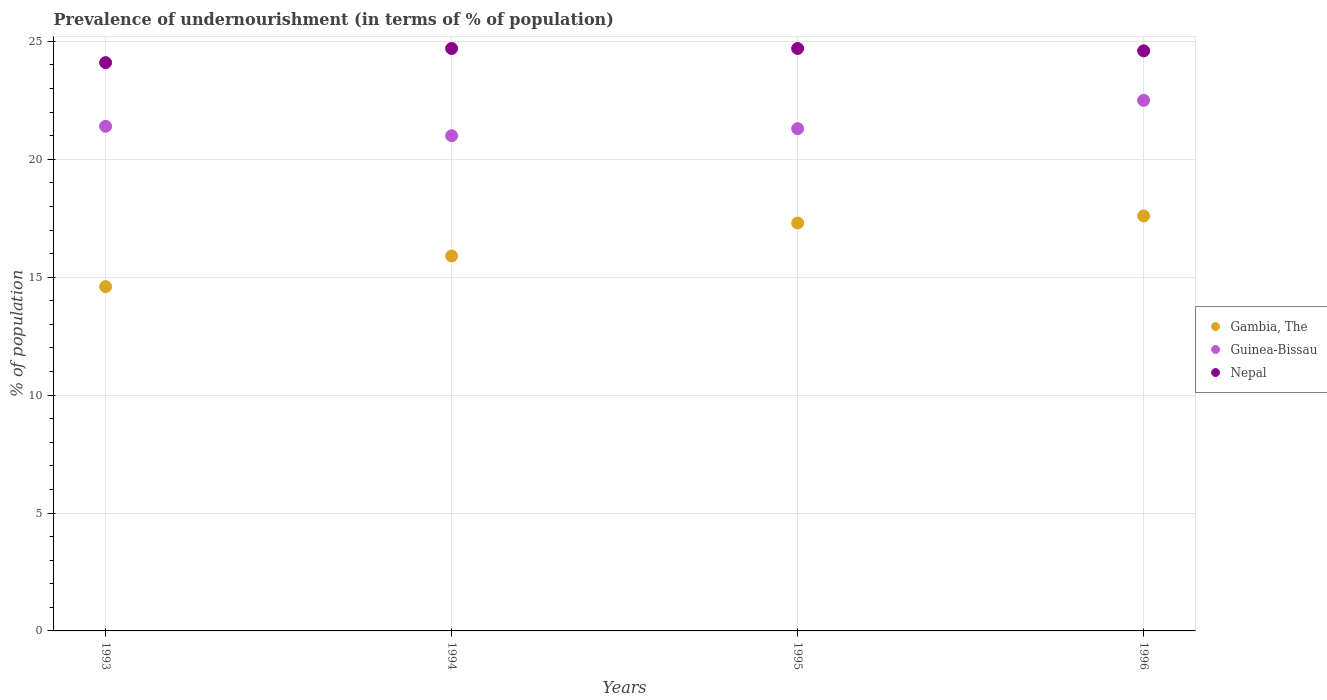What is the percentage of undernourished population in Nepal in 1993?
Make the answer very short. 24.1. Across all years, what is the maximum percentage of undernourished population in Nepal?
Provide a short and direct response. 24.7. Across all years, what is the minimum percentage of undernourished population in Nepal?
Make the answer very short. 24.1. In which year was the percentage of undernourished population in Gambia, The maximum?
Offer a very short reply. 1996. What is the total percentage of undernourished population in Gambia, The in the graph?
Make the answer very short. 65.4. What is the difference between the percentage of undernourished population in Gambia, The in 1993 and that in 1994?
Provide a succinct answer. -1.3. What is the difference between the percentage of undernourished population in Gambia, The in 1993 and the percentage of undernourished population in Nepal in 1996?
Offer a very short reply. -10. What is the average percentage of undernourished population in Nepal per year?
Make the answer very short. 24.52. In the year 1996, what is the difference between the percentage of undernourished population in Gambia, The and percentage of undernourished population in Nepal?
Make the answer very short. -7. In how many years, is the percentage of undernourished population in Nepal greater than 22 %?
Offer a very short reply. 4. What is the ratio of the percentage of undernourished population in Gambia, The in 1994 to that in 1996?
Your response must be concise. 0.9. Is the percentage of undernourished population in Guinea-Bissau in 1993 less than that in 1996?
Provide a succinct answer. Yes. Is the difference between the percentage of undernourished population in Gambia, The in 1995 and 1996 greater than the difference between the percentage of undernourished population in Nepal in 1995 and 1996?
Give a very brief answer. No. What is the difference between the highest and the lowest percentage of undernourished population in Gambia, The?
Provide a short and direct response. 3. Is the sum of the percentage of undernourished population in Gambia, The in 1994 and 1995 greater than the maximum percentage of undernourished population in Guinea-Bissau across all years?
Provide a short and direct response. Yes. Is it the case that in every year, the sum of the percentage of undernourished population in Gambia, The and percentage of undernourished population in Guinea-Bissau  is greater than the percentage of undernourished population in Nepal?
Provide a succinct answer. Yes. Is the percentage of undernourished population in Nepal strictly less than the percentage of undernourished population in Guinea-Bissau over the years?
Provide a short and direct response. No. How many dotlines are there?
Your answer should be very brief. 3. What is the difference between two consecutive major ticks on the Y-axis?
Provide a succinct answer. 5. Are the values on the major ticks of Y-axis written in scientific E-notation?
Make the answer very short. No. Does the graph contain any zero values?
Your answer should be compact. No. Does the graph contain grids?
Make the answer very short. Yes. How many legend labels are there?
Your answer should be compact. 3. What is the title of the graph?
Offer a terse response. Prevalence of undernourishment (in terms of % of population). Does "Marshall Islands" appear as one of the legend labels in the graph?
Keep it short and to the point. No. What is the label or title of the Y-axis?
Make the answer very short. % of population. What is the % of population in Guinea-Bissau in 1993?
Your answer should be compact. 21.4. What is the % of population of Nepal in 1993?
Keep it short and to the point. 24.1. What is the % of population of Guinea-Bissau in 1994?
Keep it short and to the point. 21. What is the % of population of Nepal in 1994?
Your answer should be very brief. 24.7. What is the % of population of Gambia, The in 1995?
Your answer should be very brief. 17.3. What is the % of population in Guinea-Bissau in 1995?
Provide a succinct answer. 21.3. What is the % of population in Nepal in 1995?
Keep it short and to the point. 24.7. What is the % of population of Gambia, The in 1996?
Your answer should be compact. 17.6. What is the % of population in Guinea-Bissau in 1996?
Provide a succinct answer. 22.5. What is the % of population of Nepal in 1996?
Make the answer very short. 24.6. Across all years, what is the maximum % of population of Gambia, The?
Your answer should be very brief. 17.6. Across all years, what is the maximum % of population in Guinea-Bissau?
Your answer should be compact. 22.5. Across all years, what is the maximum % of population in Nepal?
Provide a short and direct response. 24.7. Across all years, what is the minimum % of population of Nepal?
Ensure brevity in your answer.  24.1. What is the total % of population in Gambia, The in the graph?
Offer a terse response. 65.4. What is the total % of population in Guinea-Bissau in the graph?
Offer a very short reply. 86.2. What is the total % of population of Nepal in the graph?
Give a very brief answer. 98.1. What is the difference between the % of population of Gambia, The in 1993 and that in 1994?
Your answer should be compact. -1.3. What is the difference between the % of population in Guinea-Bissau in 1993 and that in 1994?
Provide a succinct answer. 0.4. What is the difference between the % of population in Gambia, The in 1993 and that in 1995?
Offer a terse response. -2.7. What is the difference between the % of population in Guinea-Bissau in 1993 and that in 1995?
Keep it short and to the point. 0.1. What is the difference between the % of population in Nepal in 1993 and that in 1995?
Keep it short and to the point. -0.6. What is the difference between the % of population in Guinea-Bissau in 1993 and that in 1996?
Ensure brevity in your answer.  -1.1. What is the difference between the % of population of Nepal in 1993 and that in 1996?
Offer a very short reply. -0.5. What is the difference between the % of population in Nepal in 1994 and that in 1995?
Offer a terse response. 0. What is the difference between the % of population in Gambia, The in 1994 and that in 1996?
Provide a short and direct response. -1.7. What is the difference between the % of population of Gambia, The in 1995 and that in 1996?
Provide a succinct answer. -0.3. What is the difference between the % of population of Nepal in 1995 and that in 1996?
Offer a very short reply. 0.1. What is the difference between the % of population in Gambia, The in 1993 and the % of population in Guinea-Bissau in 1994?
Your answer should be compact. -6.4. What is the difference between the % of population of Guinea-Bissau in 1993 and the % of population of Nepal in 1994?
Keep it short and to the point. -3.3. What is the difference between the % of population of Gambia, The in 1993 and the % of population of Nepal in 1995?
Provide a succinct answer. -10.1. What is the difference between the % of population of Guinea-Bissau in 1993 and the % of population of Nepal in 1995?
Your answer should be very brief. -3.3. What is the difference between the % of population of Gambia, The in 1993 and the % of population of Guinea-Bissau in 1996?
Provide a short and direct response. -7.9. What is the difference between the % of population of Gambia, The in 1994 and the % of population of Nepal in 1995?
Your response must be concise. -8.8. What is the difference between the % of population in Gambia, The in 1994 and the % of population in Guinea-Bissau in 1996?
Your answer should be very brief. -6.6. What is the difference between the % of population of Gambia, The in 1994 and the % of population of Nepal in 1996?
Ensure brevity in your answer.  -8.7. What is the difference between the % of population of Guinea-Bissau in 1994 and the % of population of Nepal in 1996?
Ensure brevity in your answer.  -3.6. What is the difference between the % of population in Gambia, The in 1995 and the % of population in Guinea-Bissau in 1996?
Offer a very short reply. -5.2. What is the difference between the % of population of Gambia, The in 1995 and the % of population of Nepal in 1996?
Your answer should be compact. -7.3. What is the difference between the % of population of Guinea-Bissau in 1995 and the % of population of Nepal in 1996?
Offer a terse response. -3.3. What is the average % of population in Gambia, The per year?
Your response must be concise. 16.35. What is the average % of population of Guinea-Bissau per year?
Provide a succinct answer. 21.55. What is the average % of population in Nepal per year?
Keep it short and to the point. 24.52. In the year 1993, what is the difference between the % of population in Gambia, The and % of population in Guinea-Bissau?
Keep it short and to the point. -6.8. In the year 1993, what is the difference between the % of population of Gambia, The and % of population of Nepal?
Your answer should be very brief. -9.5. In the year 1993, what is the difference between the % of population of Guinea-Bissau and % of population of Nepal?
Ensure brevity in your answer.  -2.7. In the year 1994, what is the difference between the % of population in Gambia, The and % of population in Guinea-Bissau?
Your response must be concise. -5.1. In the year 1994, what is the difference between the % of population of Guinea-Bissau and % of population of Nepal?
Provide a short and direct response. -3.7. In the year 1995, what is the difference between the % of population of Gambia, The and % of population of Nepal?
Your answer should be very brief. -7.4. In the year 1996, what is the difference between the % of population of Gambia, The and % of population of Nepal?
Provide a short and direct response. -7. What is the ratio of the % of population in Gambia, The in 1993 to that in 1994?
Your answer should be very brief. 0.92. What is the ratio of the % of population in Guinea-Bissau in 1993 to that in 1994?
Make the answer very short. 1.02. What is the ratio of the % of population of Nepal in 1993 to that in 1994?
Offer a very short reply. 0.98. What is the ratio of the % of population in Gambia, The in 1993 to that in 1995?
Your response must be concise. 0.84. What is the ratio of the % of population in Guinea-Bissau in 1993 to that in 1995?
Make the answer very short. 1. What is the ratio of the % of population of Nepal in 1993 to that in 1995?
Make the answer very short. 0.98. What is the ratio of the % of population of Gambia, The in 1993 to that in 1996?
Provide a succinct answer. 0.83. What is the ratio of the % of population of Guinea-Bissau in 1993 to that in 1996?
Give a very brief answer. 0.95. What is the ratio of the % of population of Nepal in 1993 to that in 1996?
Provide a succinct answer. 0.98. What is the ratio of the % of population of Gambia, The in 1994 to that in 1995?
Your response must be concise. 0.92. What is the ratio of the % of population of Guinea-Bissau in 1994 to that in 1995?
Give a very brief answer. 0.99. What is the ratio of the % of population in Nepal in 1994 to that in 1995?
Offer a very short reply. 1. What is the ratio of the % of population in Gambia, The in 1994 to that in 1996?
Offer a terse response. 0.9. What is the ratio of the % of population in Gambia, The in 1995 to that in 1996?
Your answer should be very brief. 0.98. What is the ratio of the % of population in Guinea-Bissau in 1995 to that in 1996?
Provide a short and direct response. 0.95. What is the ratio of the % of population of Nepal in 1995 to that in 1996?
Give a very brief answer. 1. What is the difference between the highest and the second highest % of population of Gambia, The?
Ensure brevity in your answer.  0.3. What is the difference between the highest and the second highest % of population in Nepal?
Make the answer very short. 0. What is the difference between the highest and the lowest % of population of Gambia, The?
Provide a short and direct response. 3. What is the difference between the highest and the lowest % of population of Nepal?
Your answer should be very brief. 0.6. 